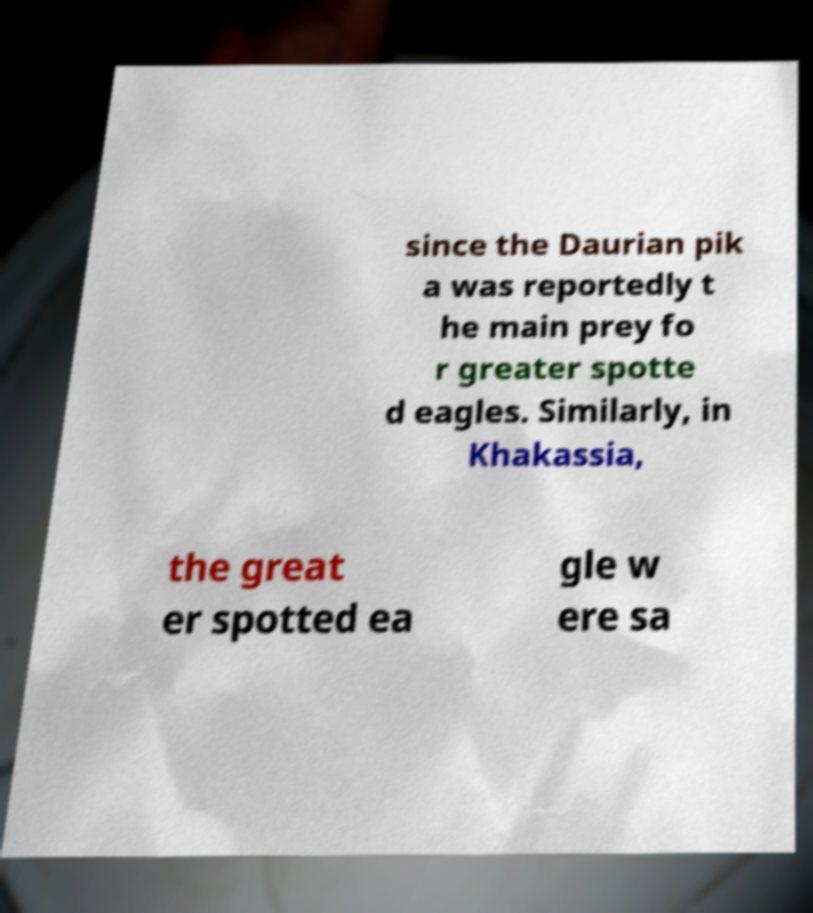Could you assist in decoding the text presented in this image and type it out clearly? since the Daurian pik a was reportedly t he main prey fo r greater spotte d eagles. Similarly, in Khakassia, the great er spotted ea gle w ere sa 